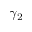<formula> <loc_0><loc_0><loc_500><loc_500>\gamma _ { 2 }</formula> 